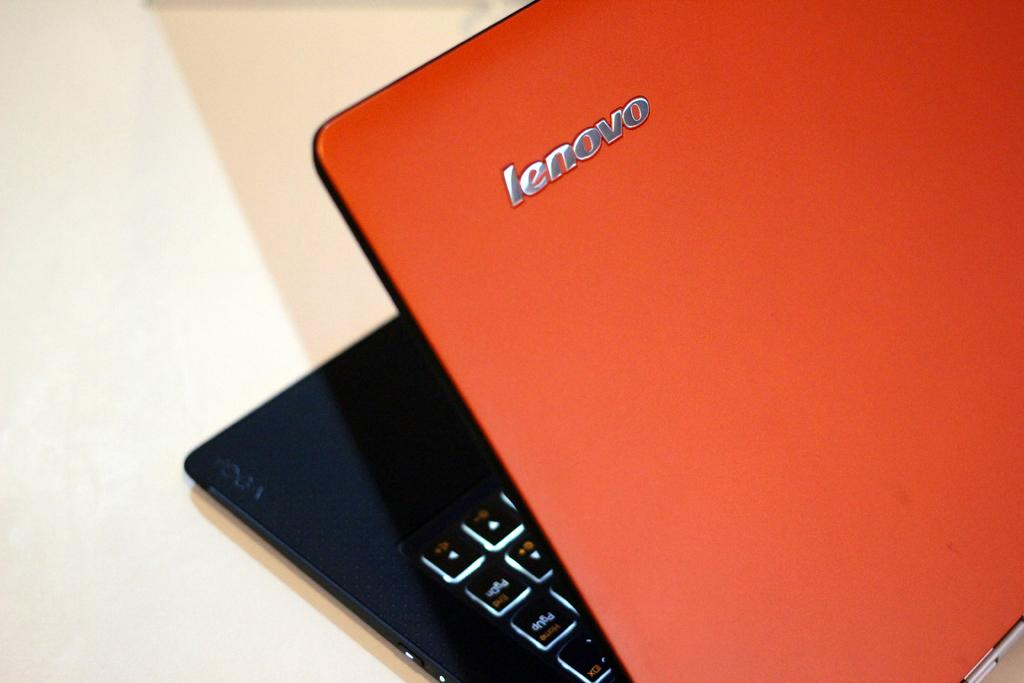<image>
Present a compact description of the photo's key features. A laptop with an orange top that says Lenovo on the top. 